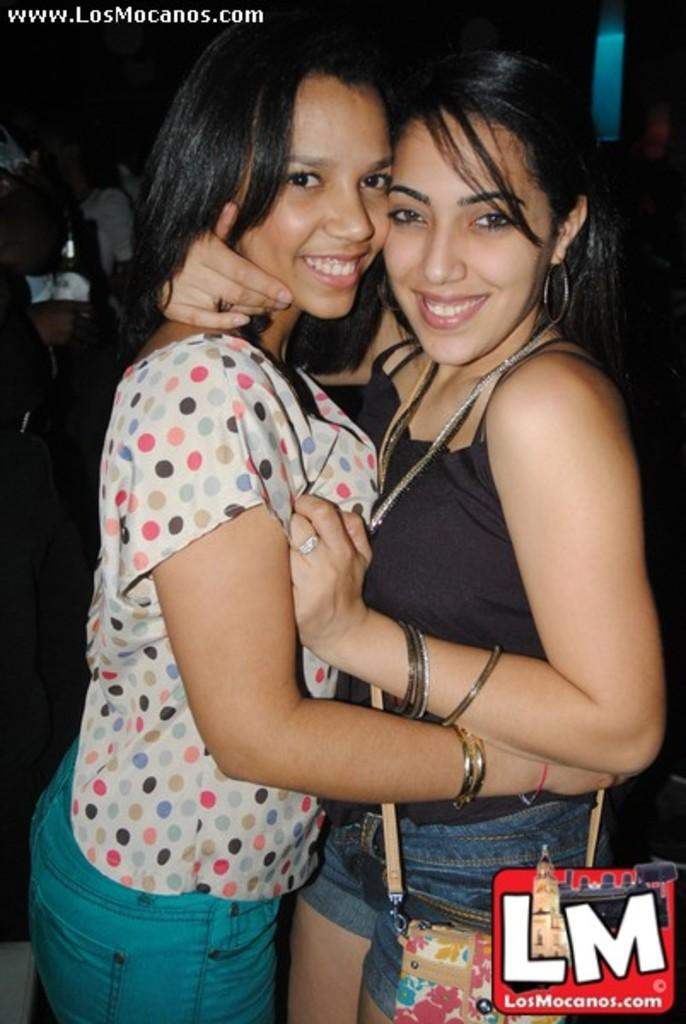How many people are in the image? There are two women in the image. What are the women doing in the image? The women are holding each other and standing. What is the emotional expression of the women in the image? The women are smiling in the image. What are the women looking at in the image? They are looking at a picture. What type of gold rings can be seen on the women's fingers in the image? There are no rings, gold or otherwise, visible on the women's fingers in the image. 